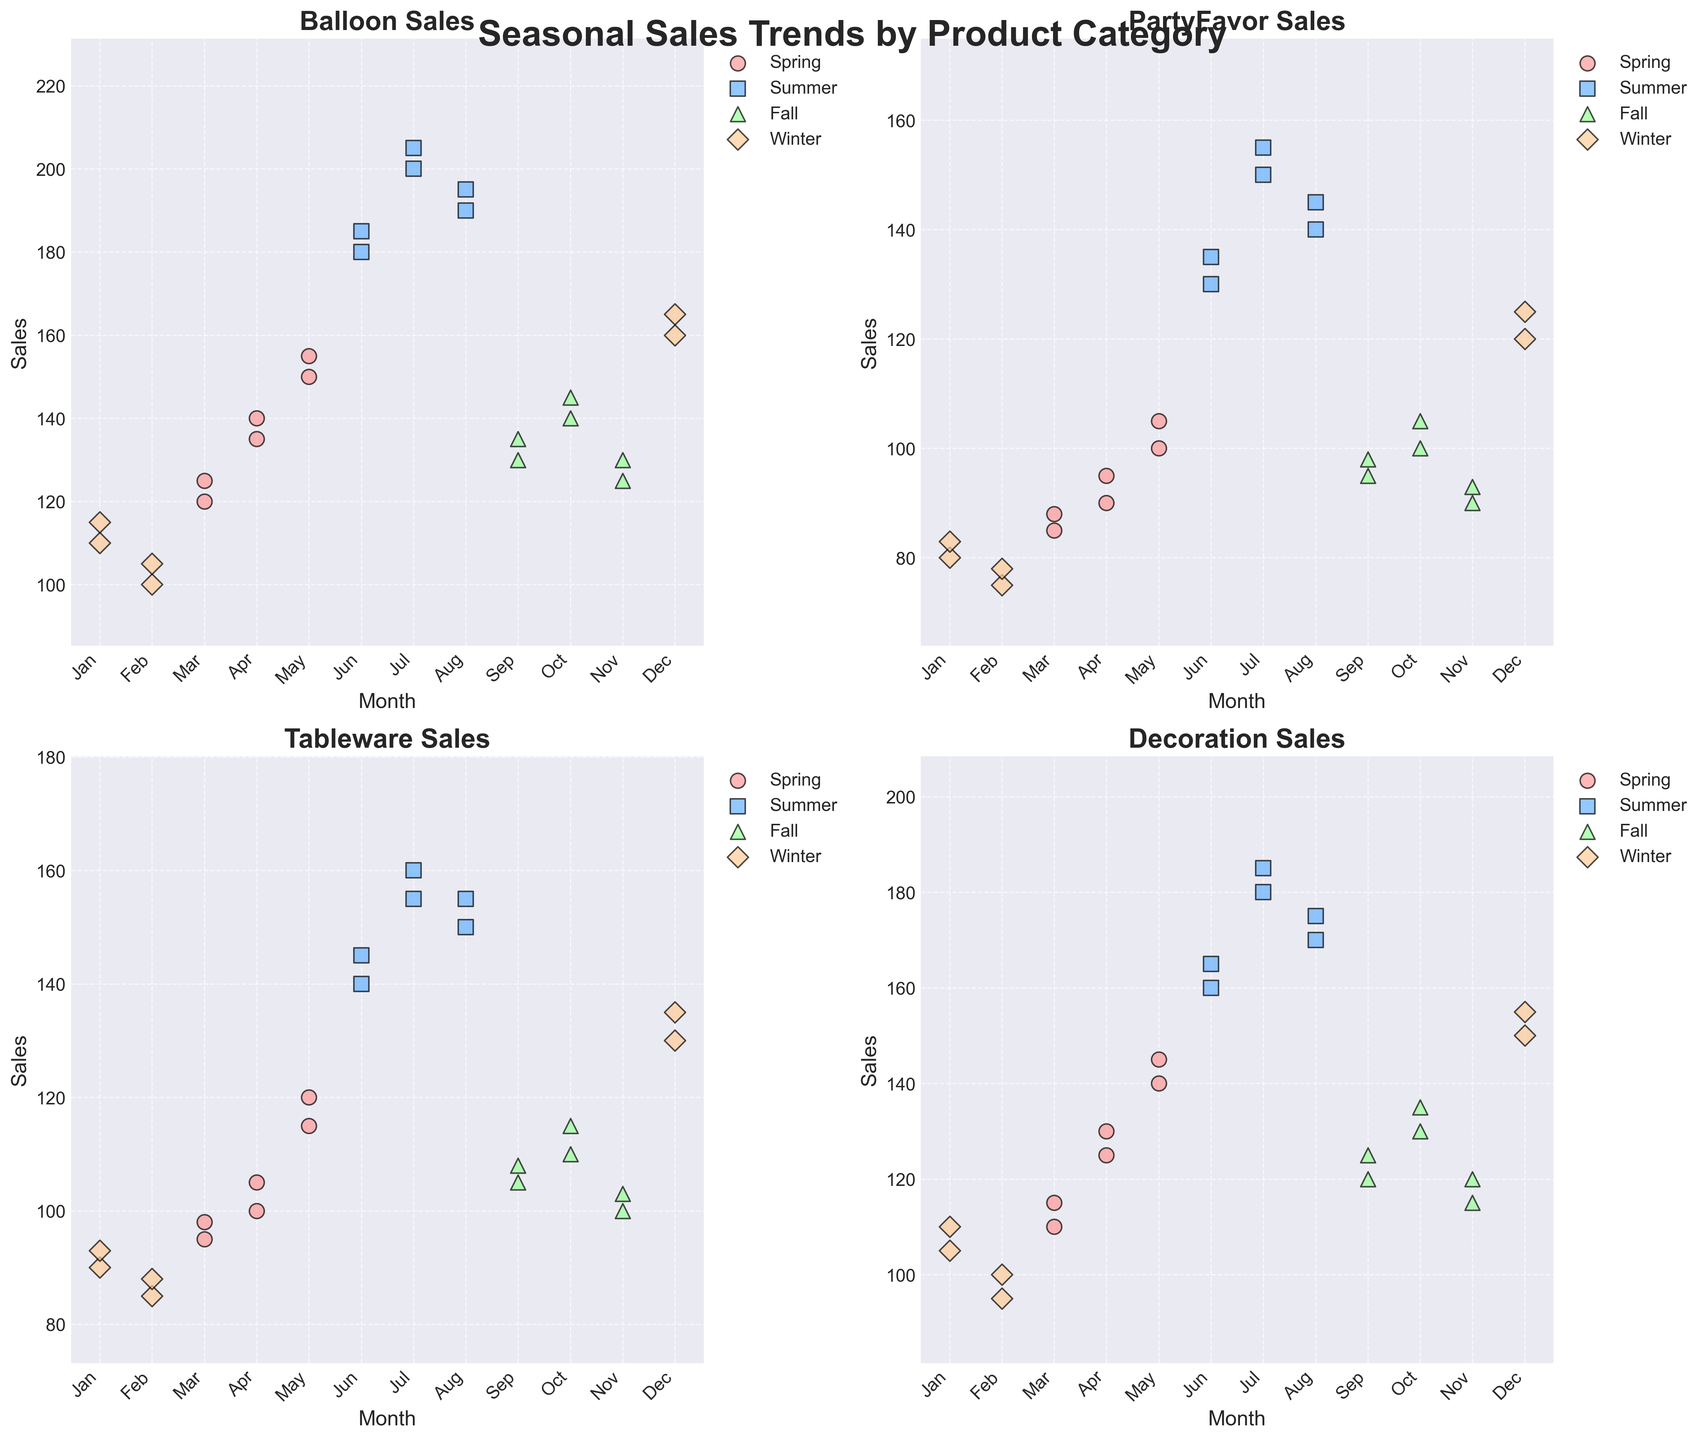What season shows the highest sales for Balloons and what month does it peak? From the Balloon Sales subplot, observe that the highest points are in the Summer months. Specifically, the highest sales are seen in July.
Answer: Summer, July Compare the Party Favor sales in the month of December for both years. Is there a significant difference? Looking at the Party Favor Sales subplot, locate the data points for December of each year. Both years show similar sales around 120-125 units, with little noticeable difference.
Answer: No significant difference Which season generally has the lowest sales for Tableware? From the Tableware Sales subplot, observe that Winter typically shows the lowest sales, with the points in January and February being the lowest compared to other seasons.
Answer: Winter During which month of Fall do Decoration sales show the highest value? In the Decoration Sales subplot, identify the months of Fall (September, October, November). The highest sales in Fall are seen in October.
Answer: October What is the average Balloon sales in Spring? Consider the Balloon Sales values in Spring: March (120, 125), April (135, 140), and May (150, 155). Calculate the average: (120 + 125 + 135 + 140 + 150 + 155) / 6 = 137.5.
Answer: 137.5 Compare the differences between June and August sales for Party Favors across two Summer periods? From the Party Favor Sales subplot: June (130, 135) and August (140, 145) for Summer months. Difference for first year: 140-130=10, second year: 145-135=10.
Answer: Both 10 What color represents the Summer season, and what marker shape is used for Balloons sales? The colors and markers for each season are consistent across subplots. Summer is represented by blue, and the marker for Balloon sales across all seasons is consistent. The figure shows that balloons use circular markers.
Answer: Blue, circle Which season has more consistent sales for Decorations, and what could indicate that? Refer to the standard deviation of decoration sales points. Summer has more consistent sales, indicated by smaller variance in sales values.
Answer: Summer 